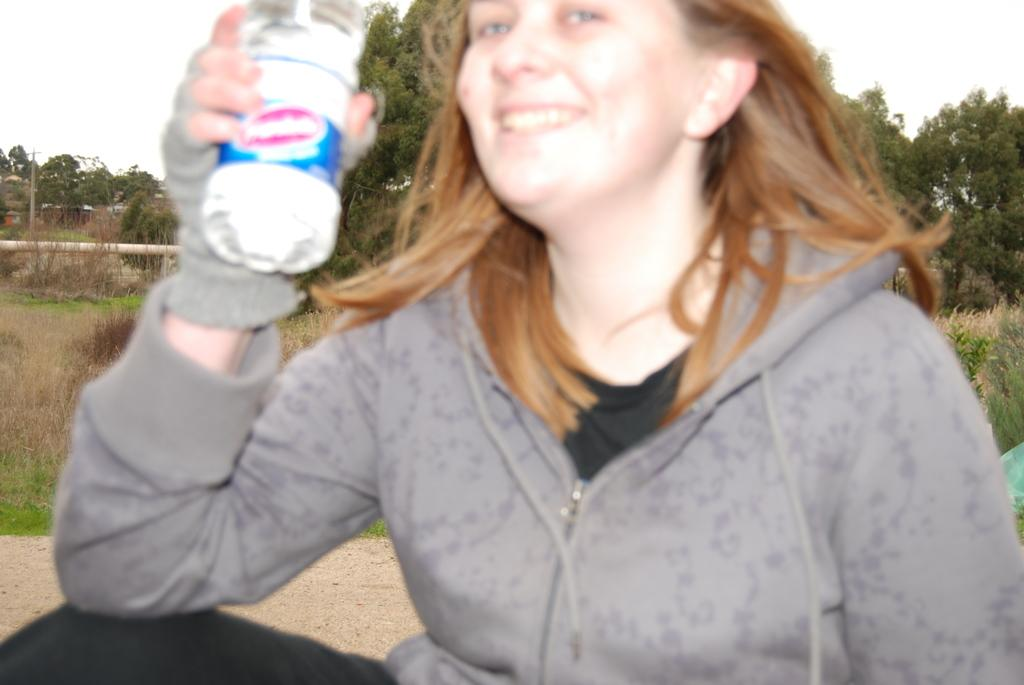Who is the main subject in the image? There is a woman in the image. What is the woman doing in the image? The woman is sitting on the ground. What is the woman holding in the image? The woman is holding a bottle. What is the expression on the woman's face? The woman has a smiling face. What type of vegetation can be seen in the background of the image? There is dry grass in the background of the image. What else can be seen in the background of the image? There are trees and the sky visible in the background of the image. What color is the hall in the image? There is no hall present in the image. What arithmetic problem is the woman solving in the image? There is no arithmetic problem visible in the image. 